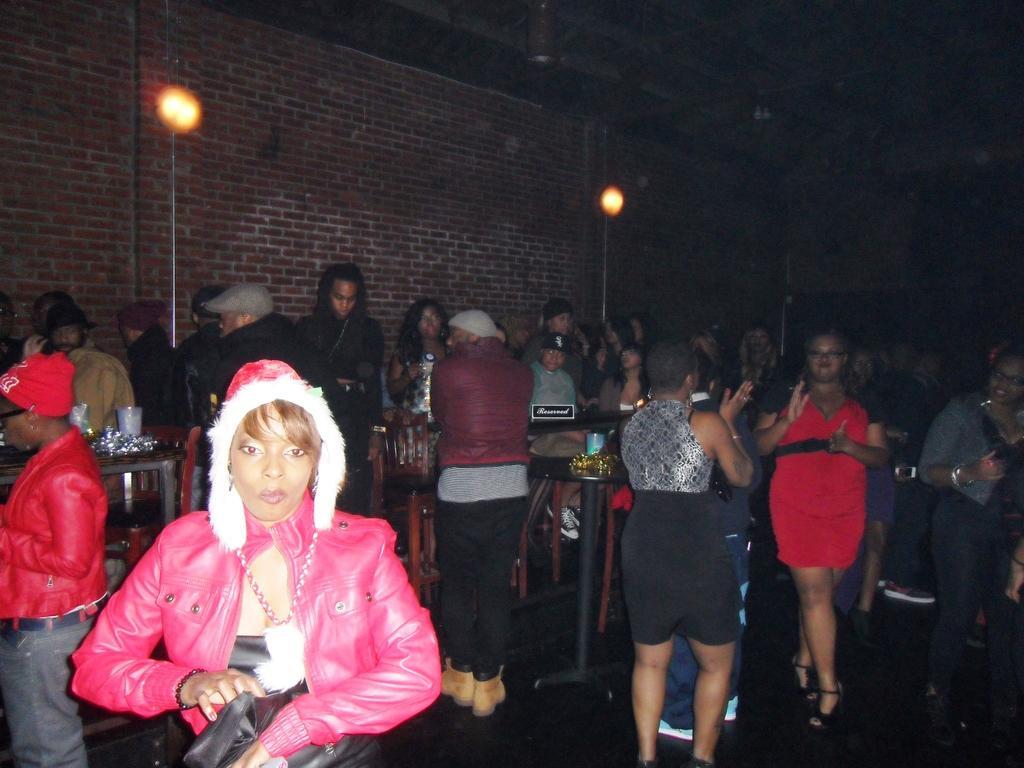Describe this image in one or two sentences. This image is taken from inside, in this image there are a few people standing on the floor, in between them there are tables and chairs are arranged, on the tables there are some food items are arranged and glasses. In the background there is a wall and lights. 